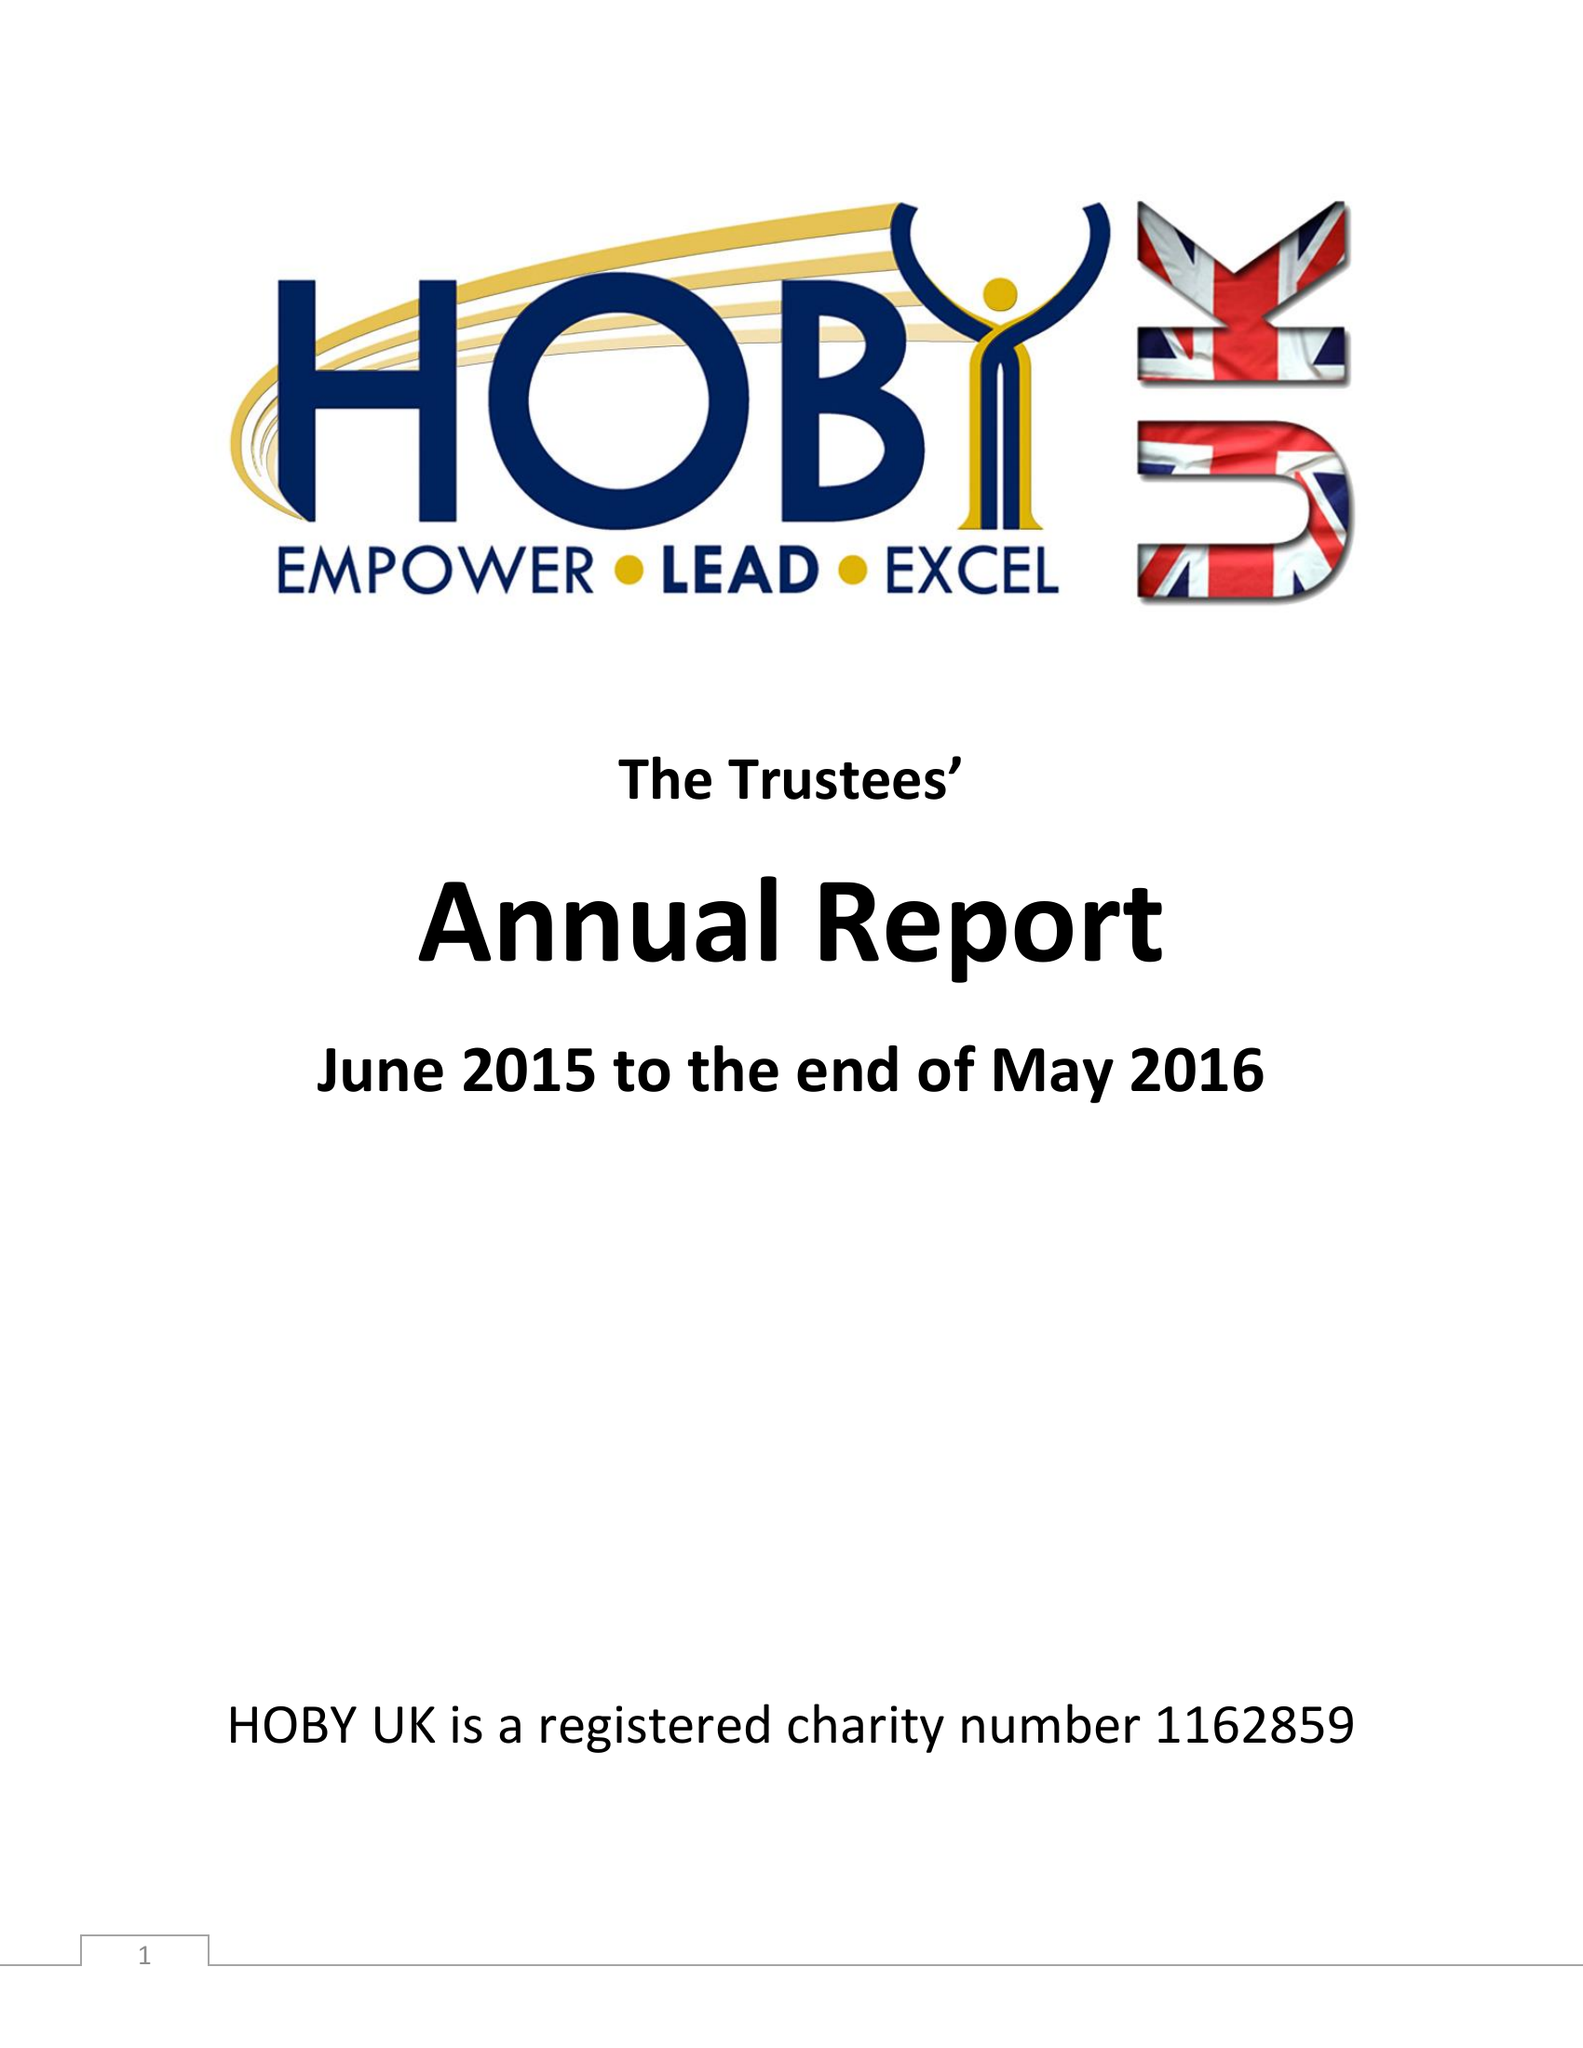What is the value for the report_date?
Answer the question using a single word or phrase. 2016-05-31 